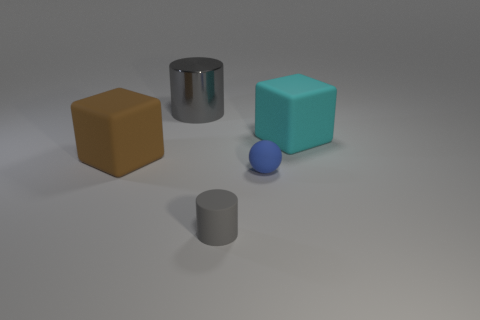Add 2 rubber blocks. How many objects exist? 7 Subtract all blocks. How many objects are left? 3 Add 5 large shiny objects. How many large shiny objects are left? 6 Add 1 tiny objects. How many tiny objects exist? 3 Subtract 0 brown balls. How many objects are left? 5 Subtract all tiny green shiny things. Subtract all blue objects. How many objects are left? 4 